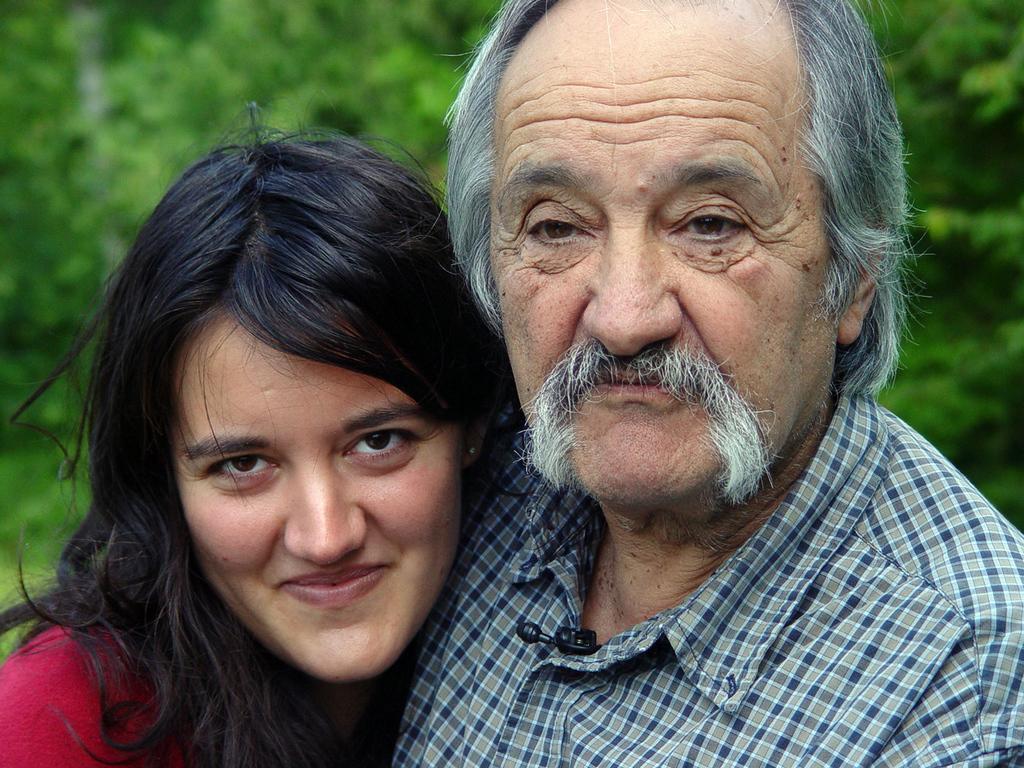Please provide a concise description of this image. In the center of the image there is man and woman. 